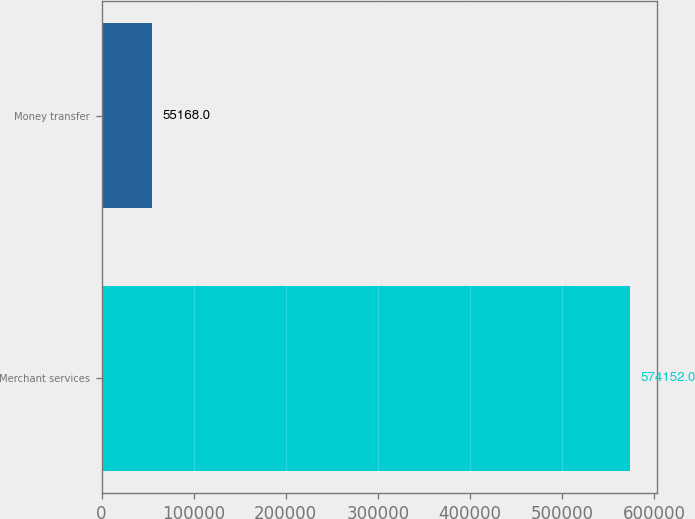<chart> <loc_0><loc_0><loc_500><loc_500><bar_chart><fcel>Merchant services<fcel>Money transfer<nl><fcel>574152<fcel>55168<nl></chart> 